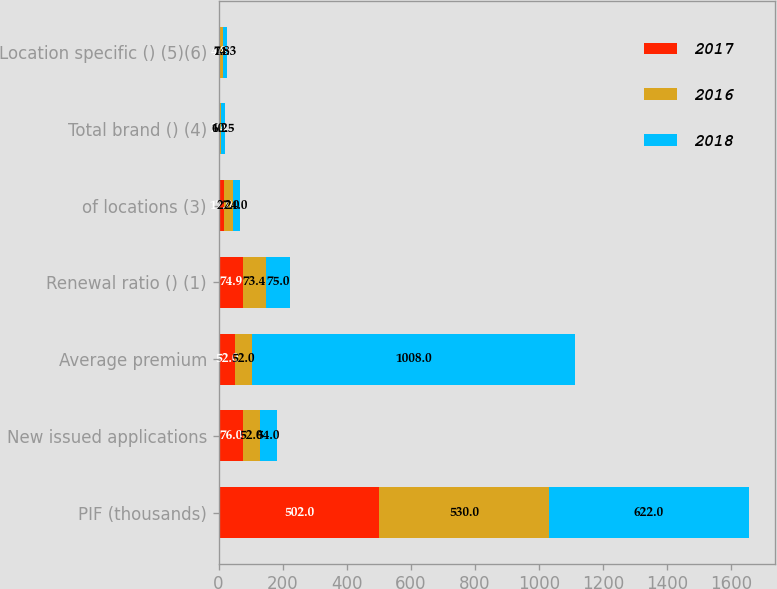Convert chart. <chart><loc_0><loc_0><loc_500><loc_500><stacked_bar_chart><ecel><fcel>PIF (thousands)<fcel>New issued applications<fcel>Average premium<fcel>Renewal ratio () (1)<fcel>of locations (3)<fcel>Total brand () (4)<fcel>Location specific () (5)(6)<nl><fcel>2017<fcel>502<fcel>76<fcel>52<fcel>74.9<fcel>17<fcel>2.4<fcel>4.8<nl><fcel>2016<fcel>530<fcel>52<fcel>52<fcel>73.4<fcel>27<fcel>6.2<fcel>7.8<nl><fcel>2018<fcel>622<fcel>54<fcel>1008<fcel>75<fcel>24<fcel>10.5<fcel>14.3<nl></chart> 